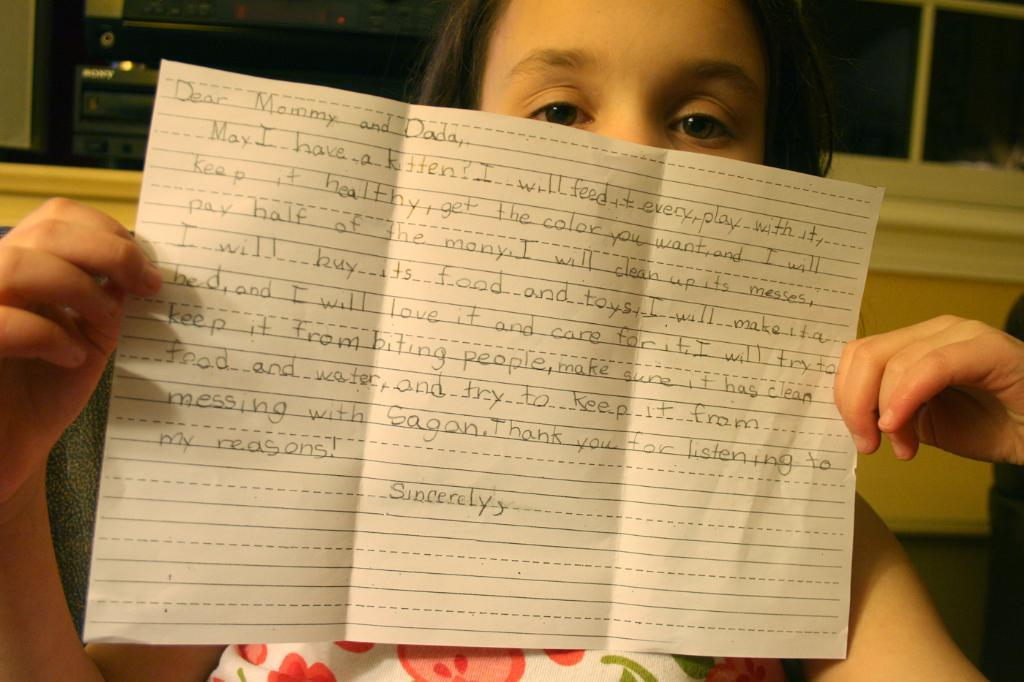Who is the main subject in the image? There is a girl in the image. What is the girl holding in the image? The girl is holding a paper. Can you describe the paper in the image? There is text on the paper. What can be seen in the background of the image? There is a wall in the background of the image. What architectural feature is present in the wall? There are windows in the wall. Can you see any ants crawling on the girl in the image? There are no ants visible in the image; the focus is on the girl holding a paper with text on it. 